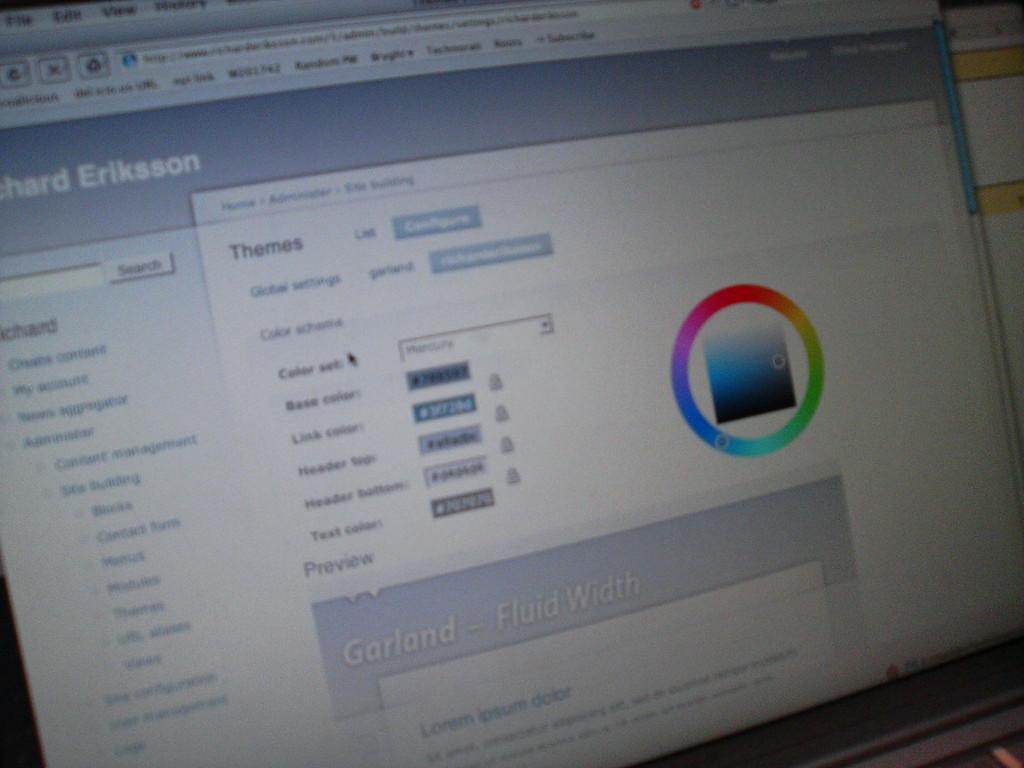<image>
Offer a succinct explanation of the picture presented. A monitor shows a window with various themes displayed. 